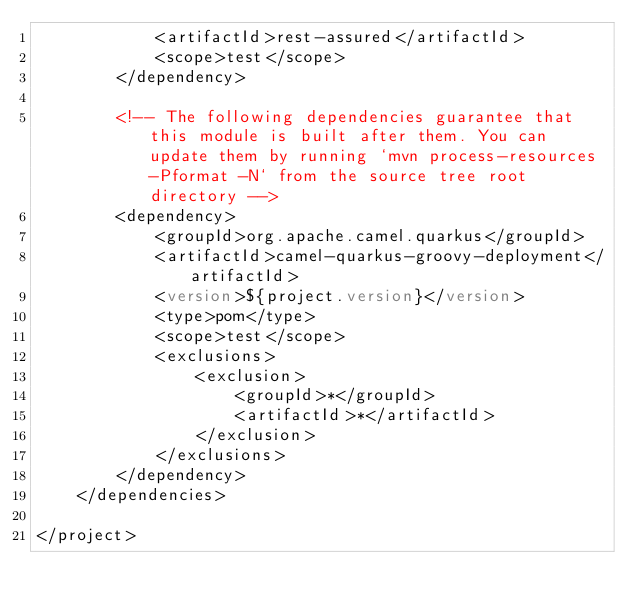<code> <loc_0><loc_0><loc_500><loc_500><_XML_>            <artifactId>rest-assured</artifactId>
            <scope>test</scope>
        </dependency>

        <!-- The following dependencies guarantee that this module is built after them. You can update them by running `mvn process-resources -Pformat -N` from the source tree root directory -->
        <dependency>
            <groupId>org.apache.camel.quarkus</groupId>
            <artifactId>camel-quarkus-groovy-deployment</artifactId>
            <version>${project.version}</version>
            <type>pom</type>
            <scope>test</scope>
            <exclusions>
                <exclusion>
                    <groupId>*</groupId>
                    <artifactId>*</artifactId>
                </exclusion>
            </exclusions>
        </dependency>
    </dependencies>

</project>
</code> 